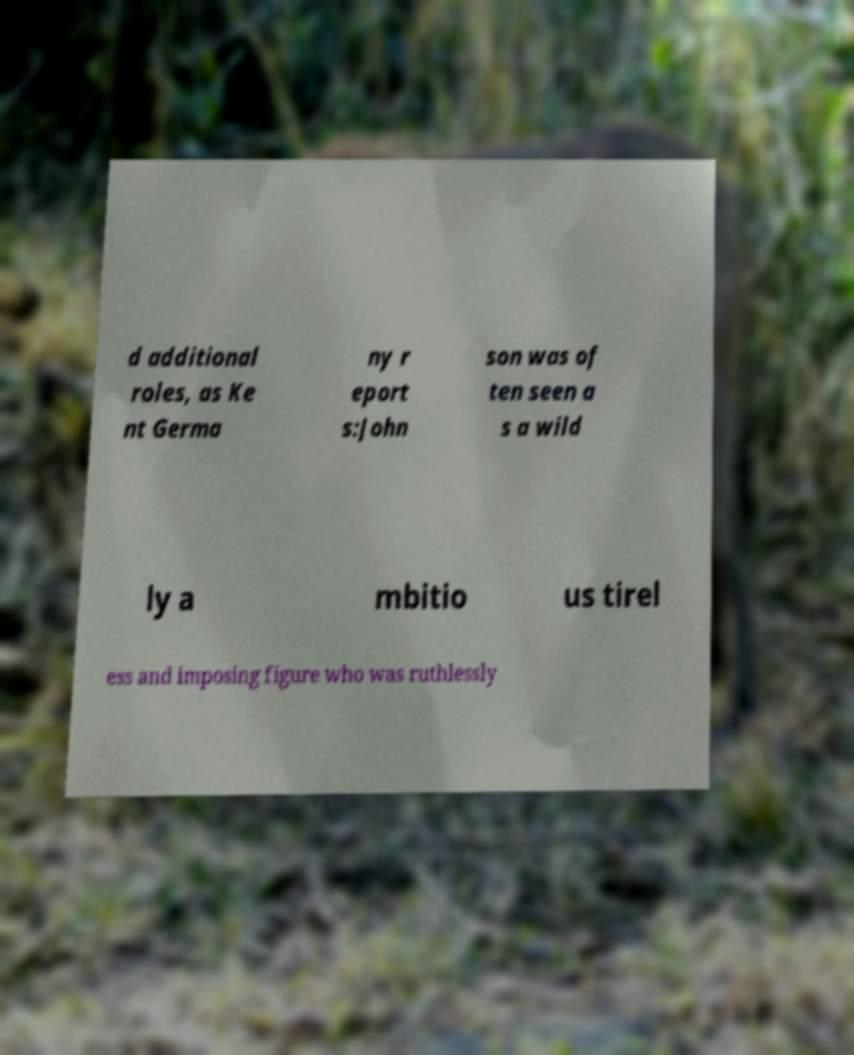For documentation purposes, I need the text within this image transcribed. Could you provide that? d additional roles, as Ke nt Germa ny r eport s:John son was of ten seen a s a wild ly a mbitio us tirel ess and imposing figure who was ruthlessly 